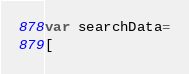Convert code to text. <code><loc_0><loc_0><loc_500><loc_500><_JavaScript_>var searchData=
[</code> 